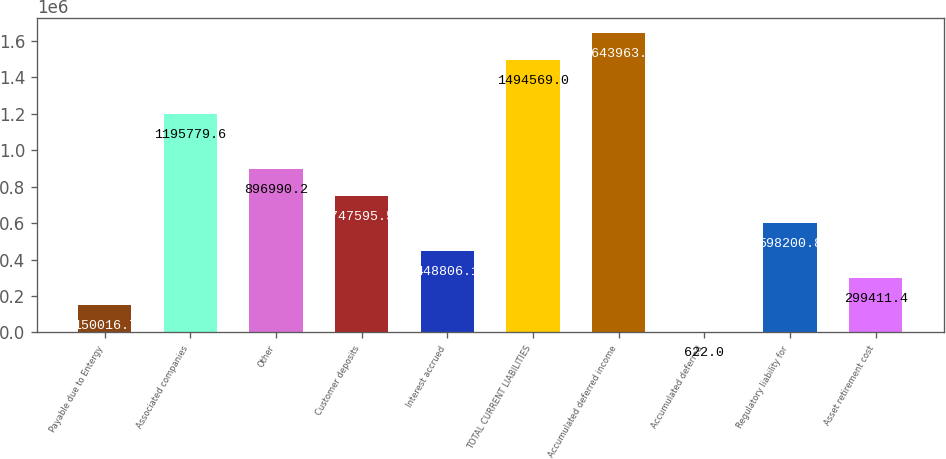Convert chart. <chart><loc_0><loc_0><loc_500><loc_500><bar_chart><fcel>Payable due to Entergy<fcel>Associated companies<fcel>Other<fcel>Customer deposits<fcel>Interest accrued<fcel>TOTAL CURRENT LIABILITIES<fcel>Accumulated deferred income<fcel>Accumulated deferred<fcel>Regulatory liability for<fcel>Asset retirement cost<nl><fcel>150017<fcel>1.19578e+06<fcel>896990<fcel>747596<fcel>448806<fcel>1.49457e+06<fcel>1.64396e+06<fcel>622<fcel>598201<fcel>299411<nl></chart> 